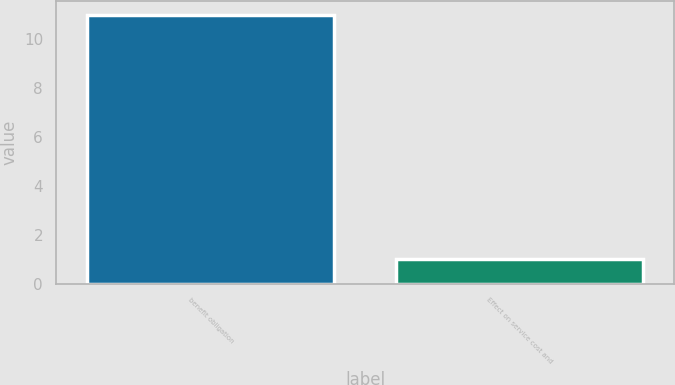<chart> <loc_0><loc_0><loc_500><loc_500><bar_chart><fcel>benefit obligation<fcel>Effect on service cost and<nl><fcel>11<fcel>1<nl></chart> 